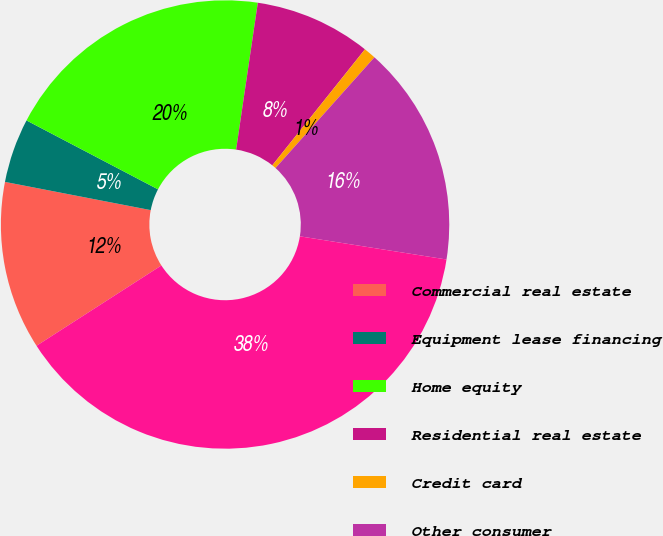<chart> <loc_0><loc_0><loc_500><loc_500><pie_chart><fcel>Commercial real estate<fcel>Equipment lease financing<fcel>Home equity<fcel>Residential real estate<fcel>Credit card<fcel>Other consumer<fcel>Total<nl><fcel>12.14%<fcel>4.64%<fcel>19.65%<fcel>8.39%<fcel>0.88%<fcel>15.89%<fcel>38.41%<nl></chart> 